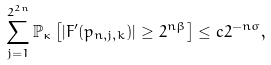Convert formula to latex. <formula><loc_0><loc_0><loc_500><loc_500>\sum _ { j = 1 } ^ { 2 ^ { 2 n } } \mathbb { P } _ { \kappa } \left [ | F ^ { \prime } ( p _ { n , j , k } ) | \geq 2 ^ { n \beta } \right ] \leq c 2 ^ { - n \sigma } ,</formula> 